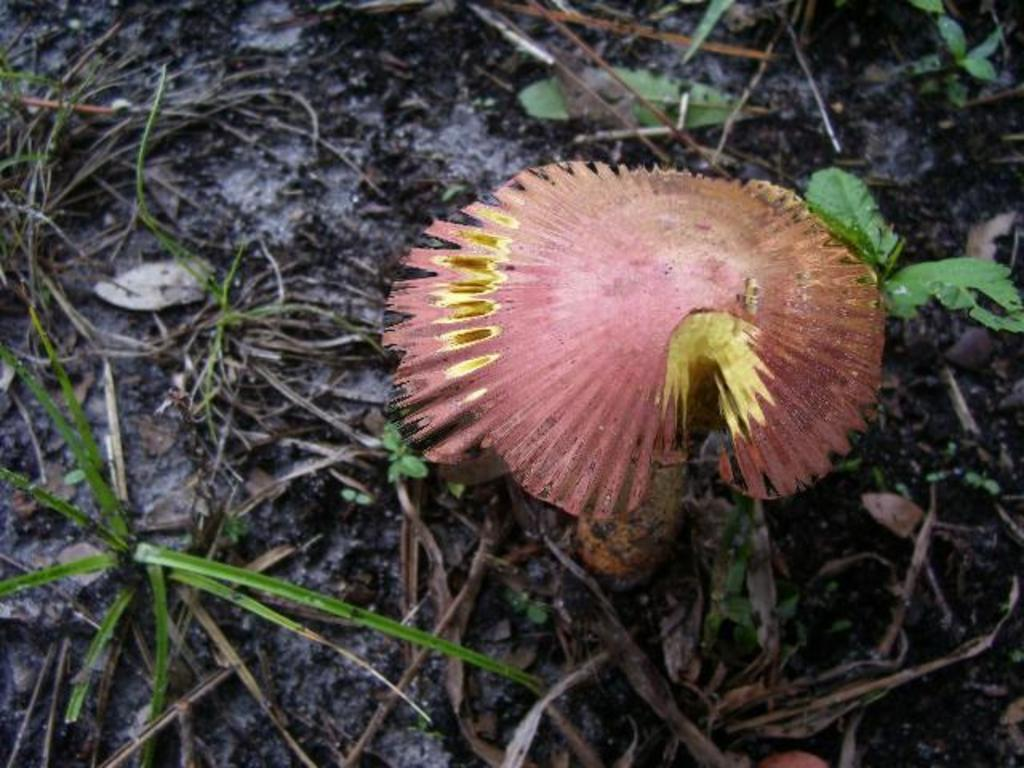What type of plant can be seen on the ground in the image? There is a mushroom on the ground in the image. What type of vegetation is visible near the mushroom? There is grass visible beside the mushroom in the image. How many eggs are being used in the operation depicted in the image? There is no operation or eggs present in the image; it features a mushroom and grass. What type of books can be seen on the shelf in the image? There is no shelf or books present in the image; it features a mushroom and grass. 